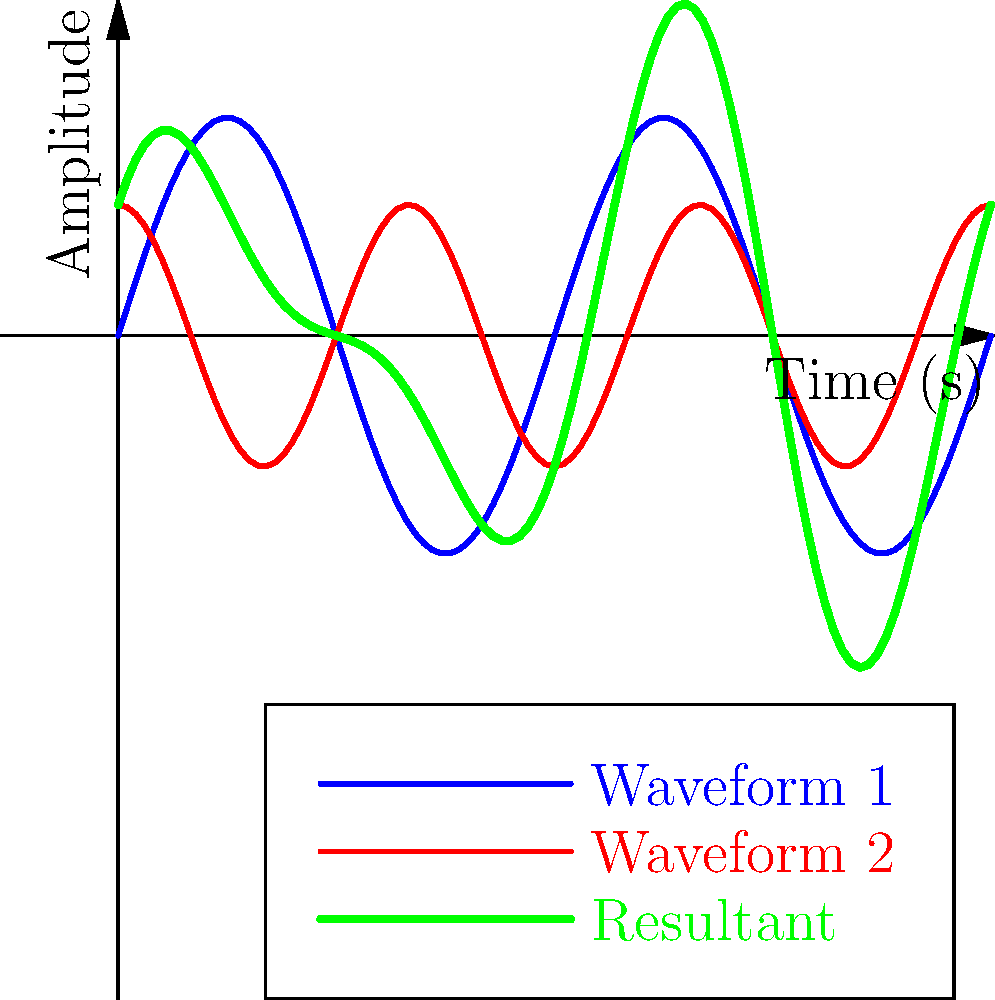As a music producer, you're working on combining two waveforms to create a unique sound. Waveform 1 is represented by the function $f_1(t) = 0.5\sin(2\pi t)$, and Waveform 2 is represented by $f_2(t) = 0.3\cos(3\pi t)$. What is the maximum amplitude of the resultant waveform when these two are combined? To find the maximum amplitude of the resultant waveform, we need to follow these steps:

1. The resultant waveform is the sum of the two individual waveforms:
   $f_3(t) = f_1(t) + f_2(t) = 0.5\sin(2\pi t) + 0.3\cos(3\pi t)$

2. The maximum amplitude of this resultant waveform will occur when both component waveforms reach their maximum values simultaneously.

3. The maximum value of $\sin(x)$ and $\cos(x)$ is 1, regardless of the frequency.

4. For $f_1(t)$, the maximum amplitude is 0.5.
   For $f_2(t)$, the maximum amplitude is 0.3.

5. In the worst-case scenario (maximum possible amplitude), these peaks would align, and we would add their absolute values:

   Maximum Amplitude = $|0.5| + |0.3| = 0.5 + 0.3 = 0.8$

Therefore, the maximum possible amplitude of the resultant waveform is 0.8.
Answer: 0.8 